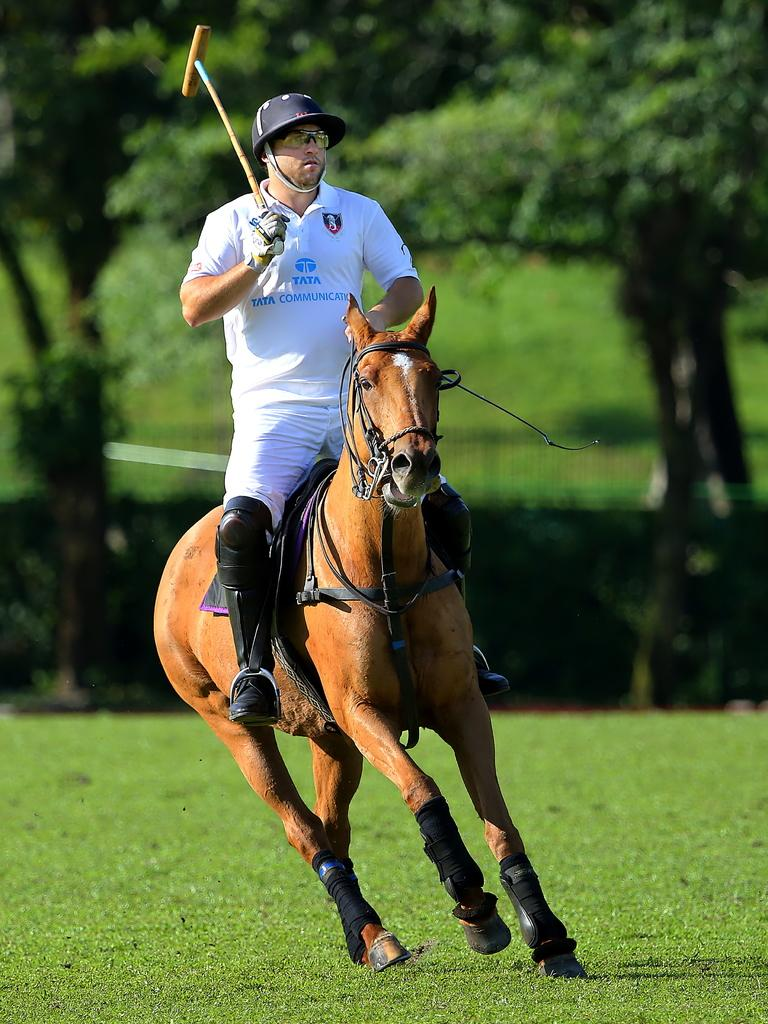What is the main subject of the image? There is a person in the image. What is the person holding in the image? The person is holding an object. What is the person doing in the image? The person is sitting on a horse. What is the horse doing in the image? The horse is running on the surface of the grass. What can be seen in the background of the image? There are trees in the background of the image. Can you tell me how many giraffes are visible in the image? There are no giraffes visible in the image; it features a person sitting on a horse running on grass with trees in the background. What type of rod is being used by the beggar in the image? There is no beggar or rod present in the image. 